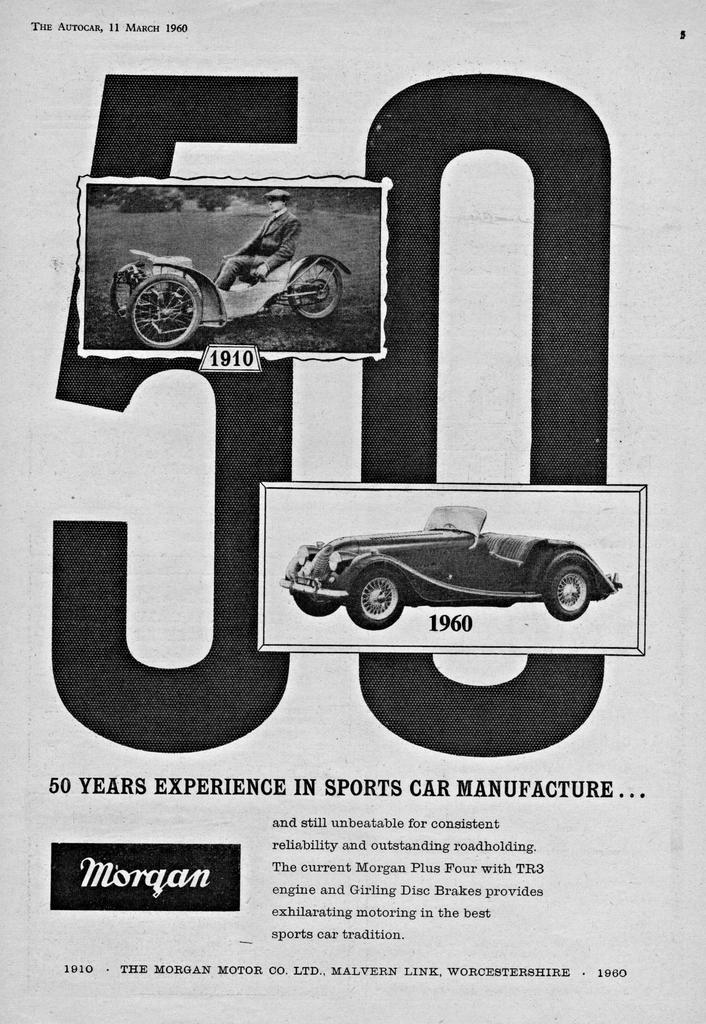What is featured in the image? There is a poster in the image. What are the colors of the poster? The poster is black and white. What can be seen on the poster besides the color scheme? There are two vehicles depicted on the poster. Is there any text on the poster? Yes, there is text written on the poster. How many babies are holding apples in the image? There are no babies or apples present in the image; it features a black and white poster with two vehicles and text. 